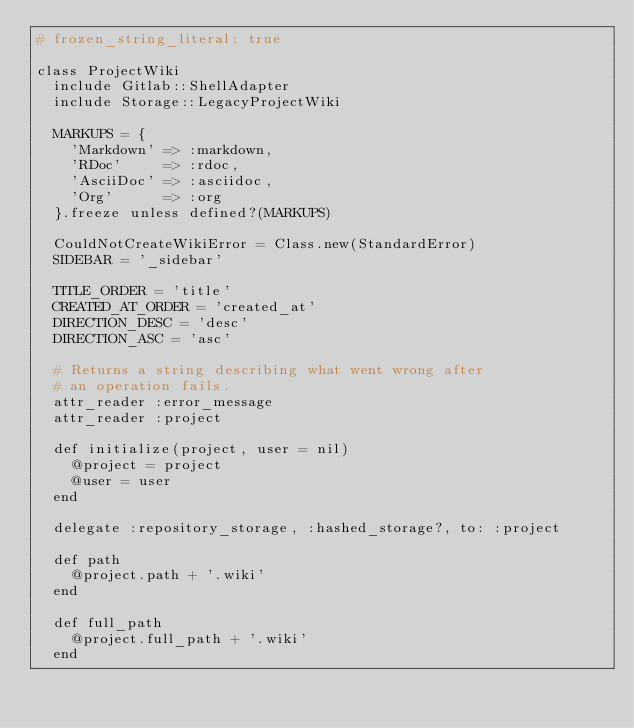Convert code to text. <code><loc_0><loc_0><loc_500><loc_500><_Ruby_># frozen_string_literal: true

class ProjectWiki
  include Gitlab::ShellAdapter
  include Storage::LegacyProjectWiki

  MARKUPS = {
    'Markdown' => :markdown,
    'RDoc'     => :rdoc,
    'AsciiDoc' => :asciidoc,
    'Org'      => :org
  }.freeze unless defined?(MARKUPS)

  CouldNotCreateWikiError = Class.new(StandardError)
  SIDEBAR = '_sidebar'

  TITLE_ORDER = 'title'
  CREATED_AT_ORDER = 'created_at'
  DIRECTION_DESC = 'desc'
  DIRECTION_ASC = 'asc'

  # Returns a string describing what went wrong after
  # an operation fails.
  attr_reader :error_message
  attr_reader :project

  def initialize(project, user = nil)
    @project = project
    @user = user
  end

  delegate :repository_storage, :hashed_storage?, to: :project

  def path
    @project.path + '.wiki'
  end

  def full_path
    @project.full_path + '.wiki'
  end
</code> 